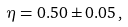Convert formula to latex. <formula><loc_0><loc_0><loc_500><loc_500>\eta = 0 . 5 0 \pm 0 . 0 5 \, ,</formula> 